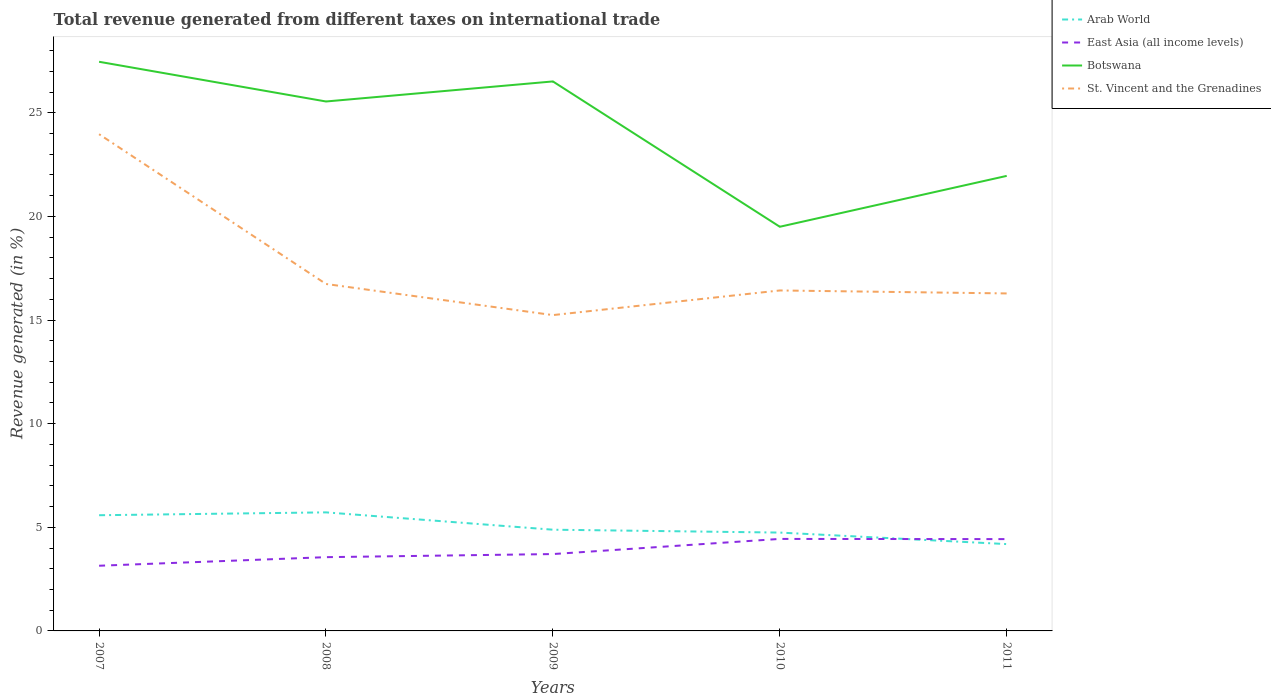How many different coloured lines are there?
Your response must be concise. 4. Across all years, what is the maximum total revenue generated in St. Vincent and the Grenadines?
Keep it short and to the point. 15.24. In which year was the total revenue generated in Arab World maximum?
Provide a succinct answer. 2011. What is the total total revenue generated in St. Vincent and the Grenadines in the graph?
Make the answer very short. 0.14. What is the difference between the highest and the second highest total revenue generated in East Asia (all income levels)?
Your answer should be very brief. 1.29. What is the difference between the highest and the lowest total revenue generated in St. Vincent and the Grenadines?
Provide a succinct answer. 1. How many lines are there?
Offer a terse response. 4. How many years are there in the graph?
Provide a short and direct response. 5. What is the difference between two consecutive major ticks on the Y-axis?
Your answer should be compact. 5. Does the graph contain any zero values?
Keep it short and to the point. No. Does the graph contain grids?
Give a very brief answer. No. What is the title of the graph?
Your response must be concise. Total revenue generated from different taxes on international trade. Does "Costa Rica" appear as one of the legend labels in the graph?
Provide a succinct answer. No. What is the label or title of the Y-axis?
Your answer should be compact. Revenue generated (in %). What is the Revenue generated (in %) in Arab World in 2007?
Make the answer very short. 5.58. What is the Revenue generated (in %) of East Asia (all income levels) in 2007?
Your answer should be very brief. 3.14. What is the Revenue generated (in %) in Botswana in 2007?
Ensure brevity in your answer.  27.46. What is the Revenue generated (in %) in St. Vincent and the Grenadines in 2007?
Your response must be concise. 23.96. What is the Revenue generated (in %) of Arab World in 2008?
Keep it short and to the point. 5.72. What is the Revenue generated (in %) in East Asia (all income levels) in 2008?
Provide a short and direct response. 3.56. What is the Revenue generated (in %) of Botswana in 2008?
Give a very brief answer. 25.54. What is the Revenue generated (in %) of St. Vincent and the Grenadines in 2008?
Your answer should be very brief. 16.74. What is the Revenue generated (in %) in Arab World in 2009?
Your answer should be very brief. 4.88. What is the Revenue generated (in %) of East Asia (all income levels) in 2009?
Your answer should be compact. 3.71. What is the Revenue generated (in %) of Botswana in 2009?
Keep it short and to the point. 26.51. What is the Revenue generated (in %) in St. Vincent and the Grenadines in 2009?
Provide a succinct answer. 15.24. What is the Revenue generated (in %) in Arab World in 2010?
Make the answer very short. 4.74. What is the Revenue generated (in %) in East Asia (all income levels) in 2010?
Give a very brief answer. 4.44. What is the Revenue generated (in %) of Botswana in 2010?
Your response must be concise. 19.5. What is the Revenue generated (in %) in St. Vincent and the Grenadines in 2010?
Offer a very short reply. 16.43. What is the Revenue generated (in %) in Arab World in 2011?
Keep it short and to the point. 4.19. What is the Revenue generated (in %) of East Asia (all income levels) in 2011?
Offer a very short reply. 4.43. What is the Revenue generated (in %) in Botswana in 2011?
Provide a short and direct response. 21.95. What is the Revenue generated (in %) in St. Vincent and the Grenadines in 2011?
Provide a succinct answer. 16.28. Across all years, what is the maximum Revenue generated (in %) of Arab World?
Make the answer very short. 5.72. Across all years, what is the maximum Revenue generated (in %) in East Asia (all income levels)?
Provide a short and direct response. 4.44. Across all years, what is the maximum Revenue generated (in %) of Botswana?
Provide a succinct answer. 27.46. Across all years, what is the maximum Revenue generated (in %) of St. Vincent and the Grenadines?
Make the answer very short. 23.96. Across all years, what is the minimum Revenue generated (in %) in Arab World?
Offer a very short reply. 4.19. Across all years, what is the minimum Revenue generated (in %) in East Asia (all income levels)?
Provide a short and direct response. 3.14. Across all years, what is the minimum Revenue generated (in %) of Botswana?
Your answer should be very brief. 19.5. Across all years, what is the minimum Revenue generated (in %) of St. Vincent and the Grenadines?
Provide a succinct answer. 15.24. What is the total Revenue generated (in %) of Arab World in the graph?
Ensure brevity in your answer.  25.12. What is the total Revenue generated (in %) of East Asia (all income levels) in the graph?
Make the answer very short. 19.28. What is the total Revenue generated (in %) in Botswana in the graph?
Your answer should be compact. 120.96. What is the total Revenue generated (in %) of St. Vincent and the Grenadines in the graph?
Ensure brevity in your answer.  88.65. What is the difference between the Revenue generated (in %) of Arab World in 2007 and that in 2008?
Make the answer very short. -0.14. What is the difference between the Revenue generated (in %) of East Asia (all income levels) in 2007 and that in 2008?
Offer a very short reply. -0.41. What is the difference between the Revenue generated (in %) in Botswana in 2007 and that in 2008?
Your answer should be very brief. 1.92. What is the difference between the Revenue generated (in %) of St. Vincent and the Grenadines in 2007 and that in 2008?
Your answer should be compact. 7.23. What is the difference between the Revenue generated (in %) in Arab World in 2007 and that in 2009?
Your answer should be very brief. 0.7. What is the difference between the Revenue generated (in %) of East Asia (all income levels) in 2007 and that in 2009?
Ensure brevity in your answer.  -0.56. What is the difference between the Revenue generated (in %) of Botswana in 2007 and that in 2009?
Your response must be concise. 0.95. What is the difference between the Revenue generated (in %) of St. Vincent and the Grenadines in 2007 and that in 2009?
Your answer should be very brief. 8.73. What is the difference between the Revenue generated (in %) of Arab World in 2007 and that in 2010?
Ensure brevity in your answer.  0.84. What is the difference between the Revenue generated (in %) in East Asia (all income levels) in 2007 and that in 2010?
Ensure brevity in your answer.  -1.29. What is the difference between the Revenue generated (in %) of Botswana in 2007 and that in 2010?
Offer a terse response. 7.96. What is the difference between the Revenue generated (in %) in St. Vincent and the Grenadines in 2007 and that in 2010?
Provide a short and direct response. 7.54. What is the difference between the Revenue generated (in %) in Arab World in 2007 and that in 2011?
Your answer should be very brief. 1.39. What is the difference between the Revenue generated (in %) in East Asia (all income levels) in 2007 and that in 2011?
Ensure brevity in your answer.  -1.28. What is the difference between the Revenue generated (in %) in Botswana in 2007 and that in 2011?
Give a very brief answer. 5.51. What is the difference between the Revenue generated (in %) in St. Vincent and the Grenadines in 2007 and that in 2011?
Provide a succinct answer. 7.68. What is the difference between the Revenue generated (in %) of Arab World in 2008 and that in 2009?
Your answer should be very brief. 0.84. What is the difference between the Revenue generated (in %) of East Asia (all income levels) in 2008 and that in 2009?
Ensure brevity in your answer.  -0.15. What is the difference between the Revenue generated (in %) of Botswana in 2008 and that in 2009?
Offer a very short reply. -0.97. What is the difference between the Revenue generated (in %) in St. Vincent and the Grenadines in 2008 and that in 2009?
Your answer should be compact. 1.5. What is the difference between the Revenue generated (in %) in Arab World in 2008 and that in 2010?
Keep it short and to the point. 0.97. What is the difference between the Revenue generated (in %) in East Asia (all income levels) in 2008 and that in 2010?
Keep it short and to the point. -0.88. What is the difference between the Revenue generated (in %) of Botswana in 2008 and that in 2010?
Your answer should be compact. 6.04. What is the difference between the Revenue generated (in %) of St. Vincent and the Grenadines in 2008 and that in 2010?
Provide a short and direct response. 0.31. What is the difference between the Revenue generated (in %) of Arab World in 2008 and that in 2011?
Keep it short and to the point. 1.53. What is the difference between the Revenue generated (in %) in East Asia (all income levels) in 2008 and that in 2011?
Offer a very short reply. -0.87. What is the difference between the Revenue generated (in %) of Botswana in 2008 and that in 2011?
Your answer should be very brief. 3.59. What is the difference between the Revenue generated (in %) in St. Vincent and the Grenadines in 2008 and that in 2011?
Offer a terse response. 0.46. What is the difference between the Revenue generated (in %) of Arab World in 2009 and that in 2010?
Give a very brief answer. 0.14. What is the difference between the Revenue generated (in %) of East Asia (all income levels) in 2009 and that in 2010?
Give a very brief answer. -0.73. What is the difference between the Revenue generated (in %) in Botswana in 2009 and that in 2010?
Your answer should be very brief. 7.01. What is the difference between the Revenue generated (in %) in St. Vincent and the Grenadines in 2009 and that in 2010?
Make the answer very short. -1.19. What is the difference between the Revenue generated (in %) in Arab World in 2009 and that in 2011?
Ensure brevity in your answer.  0.69. What is the difference between the Revenue generated (in %) of East Asia (all income levels) in 2009 and that in 2011?
Offer a terse response. -0.72. What is the difference between the Revenue generated (in %) of Botswana in 2009 and that in 2011?
Your answer should be very brief. 4.56. What is the difference between the Revenue generated (in %) in St. Vincent and the Grenadines in 2009 and that in 2011?
Keep it short and to the point. -1.04. What is the difference between the Revenue generated (in %) of Arab World in 2010 and that in 2011?
Your response must be concise. 0.56. What is the difference between the Revenue generated (in %) of East Asia (all income levels) in 2010 and that in 2011?
Give a very brief answer. 0.01. What is the difference between the Revenue generated (in %) in Botswana in 2010 and that in 2011?
Your answer should be very brief. -2.45. What is the difference between the Revenue generated (in %) in St. Vincent and the Grenadines in 2010 and that in 2011?
Make the answer very short. 0.14. What is the difference between the Revenue generated (in %) of Arab World in 2007 and the Revenue generated (in %) of East Asia (all income levels) in 2008?
Make the answer very short. 2.02. What is the difference between the Revenue generated (in %) of Arab World in 2007 and the Revenue generated (in %) of Botswana in 2008?
Ensure brevity in your answer.  -19.96. What is the difference between the Revenue generated (in %) of Arab World in 2007 and the Revenue generated (in %) of St. Vincent and the Grenadines in 2008?
Your answer should be very brief. -11.16. What is the difference between the Revenue generated (in %) in East Asia (all income levels) in 2007 and the Revenue generated (in %) in Botswana in 2008?
Provide a succinct answer. -22.4. What is the difference between the Revenue generated (in %) in East Asia (all income levels) in 2007 and the Revenue generated (in %) in St. Vincent and the Grenadines in 2008?
Offer a very short reply. -13.59. What is the difference between the Revenue generated (in %) of Botswana in 2007 and the Revenue generated (in %) of St. Vincent and the Grenadines in 2008?
Provide a short and direct response. 10.72. What is the difference between the Revenue generated (in %) in Arab World in 2007 and the Revenue generated (in %) in East Asia (all income levels) in 2009?
Ensure brevity in your answer.  1.87. What is the difference between the Revenue generated (in %) of Arab World in 2007 and the Revenue generated (in %) of Botswana in 2009?
Provide a succinct answer. -20.93. What is the difference between the Revenue generated (in %) in Arab World in 2007 and the Revenue generated (in %) in St. Vincent and the Grenadines in 2009?
Keep it short and to the point. -9.66. What is the difference between the Revenue generated (in %) of East Asia (all income levels) in 2007 and the Revenue generated (in %) of Botswana in 2009?
Provide a short and direct response. -23.37. What is the difference between the Revenue generated (in %) of East Asia (all income levels) in 2007 and the Revenue generated (in %) of St. Vincent and the Grenadines in 2009?
Offer a very short reply. -12.09. What is the difference between the Revenue generated (in %) in Botswana in 2007 and the Revenue generated (in %) in St. Vincent and the Grenadines in 2009?
Offer a terse response. 12.22. What is the difference between the Revenue generated (in %) of Arab World in 2007 and the Revenue generated (in %) of East Asia (all income levels) in 2010?
Offer a very short reply. 1.14. What is the difference between the Revenue generated (in %) in Arab World in 2007 and the Revenue generated (in %) in Botswana in 2010?
Keep it short and to the point. -13.92. What is the difference between the Revenue generated (in %) of Arab World in 2007 and the Revenue generated (in %) of St. Vincent and the Grenadines in 2010?
Keep it short and to the point. -10.84. What is the difference between the Revenue generated (in %) in East Asia (all income levels) in 2007 and the Revenue generated (in %) in Botswana in 2010?
Your answer should be compact. -16.35. What is the difference between the Revenue generated (in %) in East Asia (all income levels) in 2007 and the Revenue generated (in %) in St. Vincent and the Grenadines in 2010?
Keep it short and to the point. -13.28. What is the difference between the Revenue generated (in %) of Botswana in 2007 and the Revenue generated (in %) of St. Vincent and the Grenadines in 2010?
Provide a short and direct response. 11.03. What is the difference between the Revenue generated (in %) of Arab World in 2007 and the Revenue generated (in %) of East Asia (all income levels) in 2011?
Your answer should be very brief. 1.15. What is the difference between the Revenue generated (in %) in Arab World in 2007 and the Revenue generated (in %) in Botswana in 2011?
Make the answer very short. -16.37. What is the difference between the Revenue generated (in %) in Arab World in 2007 and the Revenue generated (in %) in St. Vincent and the Grenadines in 2011?
Give a very brief answer. -10.7. What is the difference between the Revenue generated (in %) in East Asia (all income levels) in 2007 and the Revenue generated (in %) in Botswana in 2011?
Make the answer very short. -18.81. What is the difference between the Revenue generated (in %) of East Asia (all income levels) in 2007 and the Revenue generated (in %) of St. Vincent and the Grenadines in 2011?
Make the answer very short. -13.14. What is the difference between the Revenue generated (in %) of Botswana in 2007 and the Revenue generated (in %) of St. Vincent and the Grenadines in 2011?
Give a very brief answer. 11.18. What is the difference between the Revenue generated (in %) of Arab World in 2008 and the Revenue generated (in %) of East Asia (all income levels) in 2009?
Give a very brief answer. 2.01. What is the difference between the Revenue generated (in %) in Arab World in 2008 and the Revenue generated (in %) in Botswana in 2009?
Your response must be concise. -20.79. What is the difference between the Revenue generated (in %) in Arab World in 2008 and the Revenue generated (in %) in St. Vincent and the Grenadines in 2009?
Ensure brevity in your answer.  -9.52. What is the difference between the Revenue generated (in %) in East Asia (all income levels) in 2008 and the Revenue generated (in %) in Botswana in 2009?
Keep it short and to the point. -22.95. What is the difference between the Revenue generated (in %) of East Asia (all income levels) in 2008 and the Revenue generated (in %) of St. Vincent and the Grenadines in 2009?
Provide a short and direct response. -11.68. What is the difference between the Revenue generated (in %) of Botswana in 2008 and the Revenue generated (in %) of St. Vincent and the Grenadines in 2009?
Make the answer very short. 10.31. What is the difference between the Revenue generated (in %) in Arab World in 2008 and the Revenue generated (in %) in East Asia (all income levels) in 2010?
Provide a succinct answer. 1.28. What is the difference between the Revenue generated (in %) in Arab World in 2008 and the Revenue generated (in %) in Botswana in 2010?
Offer a terse response. -13.78. What is the difference between the Revenue generated (in %) in Arab World in 2008 and the Revenue generated (in %) in St. Vincent and the Grenadines in 2010?
Ensure brevity in your answer.  -10.71. What is the difference between the Revenue generated (in %) of East Asia (all income levels) in 2008 and the Revenue generated (in %) of Botswana in 2010?
Your answer should be compact. -15.94. What is the difference between the Revenue generated (in %) of East Asia (all income levels) in 2008 and the Revenue generated (in %) of St. Vincent and the Grenadines in 2010?
Offer a very short reply. -12.87. What is the difference between the Revenue generated (in %) of Botswana in 2008 and the Revenue generated (in %) of St. Vincent and the Grenadines in 2010?
Keep it short and to the point. 9.12. What is the difference between the Revenue generated (in %) of Arab World in 2008 and the Revenue generated (in %) of East Asia (all income levels) in 2011?
Offer a very short reply. 1.29. What is the difference between the Revenue generated (in %) in Arab World in 2008 and the Revenue generated (in %) in Botswana in 2011?
Offer a very short reply. -16.23. What is the difference between the Revenue generated (in %) of Arab World in 2008 and the Revenue generated (in %) of St. Vincent and the Grenadines in 2011?
Ensure brevity in your answer.  -10.56. What is the difference between the Revenue generated (in %) in East Asia (all income levels) in 2008 and the Revenue generated (in %) in Botswana in 2011?
Your answer should be very brief. -18.39. What is the difference between the Revenue generated (in %) of East Asia (all income levels) in 2008 and the Revenue generated (in %) of St. Vincent and the Grenadines in 2011?
Give a very brief answer. -12.72. What is the difference between the Revenue generated (in %) of Botswana in 2008 and the Revenue generated (in %) of St. Vincent and the Grenadines in 2011?
Your answer should be very brief. 9.26. What is the difference between the Revenue generated (in %) of Arab World in 2009 and the Revenue generated (in %) of East Asia (all income levels) in 2010?
Your answer should be compact. 0.44. What is the difference between the Revenue generated (in %) in Arab World in 2009 and the Revenue generated (in %) in Botswana in 2010?
Make the answer very short. -14.62. What is the difference between the Revenue generated (in %) in Arab World in 2009 and the Revenue generated (in %) in St. Vincent and the Grenadines in 2010?
Your response must be concise. -11.54. What is the difference between the Revenue generated (in %) of East Asia (all income levels) in 2009 and the Revenue generated (in %) of Botswana in 2010?
Give a very brief answer. -15.79. What is the difference between the Revenue generated (in %) in East Asia (all income levels) in 2009 and the Revenue generated (in %) in St. Vincent and the Grenadines in 2010?
Offer a terse response. -12.72. What is the difference between the Revenue generated (in %) of Botswana in 2009 and the Revenue generated (in %) of St. Vincent and the Grenadines in 2010?
Your answer should be compact. 10.08. What is the difference between the Revenue generated (in %) in Arab World in 2009 and the Revenue generated (in %) in East Asia (all income levels) in 2011?
Provide a succinct answer. 0.45. What is the difference between the Revenue generated (in %) of Arab World in 2009 and the Revenue generated (in %) of Botswana in 2011?
Offer a very short reply. -17.07. What is the difference between the Revenue generated (in %) of Arab World in 2009 and the Revenue generated (in %) of St. Vincent and the Grenadines in 2011?
Ensure brevity in your answer.  -11.4. What is the difference between the Revenue generated (in %) of East Asia (all income levels) in 2009 and the Revenue generated (in %) of Botswana in 2011?
Offer a terse response. -18.25. What is the difference between the Revenue generated (in %) of East Asia (all income levels) in 2009 and the Revenue generated (in %) of St. Vincent and the Grenadines in 2011?
Provide a succinct answer. -12.57. What is the difference between the Revenue generated (in %) of Botswana in 2009 and the Revenue generated (in %) of St. Vincent and the Grenadines in 2011?
Make the answer very short. 10.23. What is the difference between the Revenue generated (in %) in Arab World in 2010 and the Revenue generated (in %) in East Asia (all income levels) in 2011?
Make the answer very short. 0.32. What is the difference between the Revenue generated (in %) in Arab World in 2010 and the Revenue generated (in %) in Botswana in 2011?
Keep it short and to the point. -17.21. What is the difference between the Revenue generated (in %) in Arab World in 2010 and the Revenue generated (in %) in St. Vincent and the Grenadines in 2011?
Offer a terse response. -11.54. What is the difference between the Revenue generated (in %) of East Asia (all income levels) in 2010 and the Revenue generated (in %) of Botswana in 2011?
Provide a short and direct response. -17.51. What is the difference between the Revenue generated (in %) of East Asia (all income levels) in 2010 and the Revenue generated (in %) of St. Vincent and the Grenadines in 2011?
Give a very brief answer. -11.84. What is the difference between the Revenue generated (in %) of Botswana in 2010 and the Revenue generated (in %) of St. Vincent and the Grenadines in 2011?
Your answer should be very brief. 3.22. What is the average Revenue generated (in %) in Arab World per year?
Your answer should be very brief. 5.02. What is the average Revenue generated (in %) in East Asia (all income levels) per year?
Keep it short and to the point. 3.86. What is the average Revenue generated (in %) of Botswana per year?
Your answer should be compact. 24.19. What is the average Revenue generated (in %) in St. Vincent and the Grenadines per year?
Keep it short and to the point. 17.73. In the year 2007, what is the difference between the Revenue generated (in %) of Arab World and Revenue generated (in %) of East Asia (all income levels)?
Your response must be concise. 2.44. In the year 2007, what is the difference between the Revenue generated (in %) of Arab World and Revenue generated (in %) of Botswana?
Your response must be concise. -21.88. In the year 2007, what is the difference between the Revenue generated (in %) in Arab World and Revenue generated (in %) in St. Vincent and the Grenadines?
Provide a short and direct response. -18.38. In the year 2007, what is the difference between the Revenue generated (in %) of East Asia (all income levels) and Revenue generated (in %) of Botswana?
Your answer should be very brief. -24.31. In the year 2007, what is the difference between the Revenue generated (in %) of East Asia (all income levels) and Revenue generated (in %) of St. Vincent and the Grenadines?
Offer a very short reply. -20.82. In the year 2007, what is the difference between the Revenue generated (in %) of Botswana and Revenue generated (in %) of St. Vincent and the Grenadines?
Keep it short and to the point. 3.49. In the year 2008, what is the difference between the Revenue generated (in %) in Arab World and Revenue generated (in %) in East Asia (all income levels)?
Keep it short and to the point. 2.16. In the year 2008, what is the difference between the Revenue generated (in %) in Arab World and Revenue generated (in %) in Botswana?
Your answer should be compact. -19.82. In the year 2008, what is the difference between the Revenue generated (in %) of Arab World and Revenue generated (in %) of St. Vincent and the Grenadines?
Your answer should be very brief. -11.02. In the year 2008, what is the difference between the Revenue generated (in %) in East Asia (all income levels) and Revenue generated (in %) in Botswana?
Provide a succinct answer. -21.98. In the year 2008, what is the difference between the Revenue generated (in %) in East Asia (all income levels) and Revenue generated (in %) in St. Vincent and the Grenadines?
Offer a very short reply. -13.18. In the year 2008, what is the difference between the Revenue generated (in %) in Botswana and Revenue generated (in %) in St. Vincent and the Grenadines?
Provide a succinct answer. 8.8. In the year 2009, what is the difference between the Revenue generated (in %) in Arab World and Revenue generated (in %) in East Asia (all income levels)?
Ensure brevity in your answer.  1.18. In the year 2009, what is the difference between the Revenue generated (in %) of Arab World and Revenue generated (in %) of Botswana?
Give a very brief answer. -21.63. In the year 2009, what is the difference between the Revenue generated (in %) in Arab World and Revenue generated (in %) in St. Vincent and the Grenadines?
Your response must be concise. -10.35. In the year 2009, what is the difference between the Revenue generated (in %) in East Asia (all income levels) and Revenue generated (in %) in Botswana?
Provide a short and direct response. -22.8. In the year 2009, what is the difference between the Revenue generated (in %) of East Asia (all income levels) and Revenue generated (in %) of St. Vincent and the Grenadines?
Ensure brevity in your answer.  -11.53. In the year 2009, what is the difference between the Revenue generated (in %) of Botswana and Revenue generated (in %) of St. Vincent and the Grenadines?
Offer a very short reply. 11.27. In the year 2010, what is the difference between the Revenue generated (in %) in Arab World and Revenue generated (in %) in East Asia (all income levels)?
Provide a succinct answer. 0.31. In the year 2010, what is the difference between the Revenue generated (in %) of Arab World and Revenue generated (in %) of Botswana?
Your answer should be compact. -14.75. In the year 2010, what is the difference between the Revenue generated (in %) of Arab World and Revenue generated (in %) of St. Vincent and the Grenadines?
Your response must be concise. -11.68. In the year 2010, what is the difference between the Revenue generated (in %) of East Asia (all income levels) and Revenue generated (in %) of Botswana?
Make the answer very short. -15.06. In the year 2010, what is the difference between the Revenue generated (in %) of East Asia (all income levels) and Revenue generated (in %) of St. Vincent and the Grenadines?
Your answer should be very brief. -11.99. In the year 2010, what is the difference between the Revenue generated (in %) in Botswana and Revenue generated (in %) in St. Vincent and the Grenadines?
Your answer should be very brief. 3.07. In the year 2011, what is the difference between the Revenue generated (in %) of Arab World and Revenue generated (in %) of East Asia (all income levels)?
Offer a very short reply. -0.24. In the year 2011, what is the difference between the Revenue generated (in %) of Arab World and Revenue generated (in %) of Botswana?
Give a very brief answer. -17.76. In the year 2011, what is the difference between the Revenue generated (in %) in Arab World and Revenue generated (in %) in St. Vincent and the Grenadines?
Keep it short and to the point. -12.09. In the year 2011, what is the difference between the Revenue generated (in %) in East Asia (all income levels) and Revenue generated (in %) in Botswana?
Keep it short and to the point. -17.52. In the year 2011, what is the difference between the Revenue generated (in %) of East Asia (all income levels) and Revenue generated (in %) of St. Vincent and the Grenadines?
Provide a short and direct response. -11.85. In the year 2011, what is the difference between the Revenue generated (in %) in Botswana and Revenue generated (in %) in St. Vincent and the Grenadines?
Ensure brevity in your answer.  5.67. What is the ratio of the Revenue generated (in %) of Arab World in 2007 to that in 2008?
Your answer should be compact. 0.98. What is the ratio of the Revenue generated (in %) of East Asia (all income levels) in 2007 to that in 2008?
Give a very brief answer. 0.88. What is the ratio of the Revenue generated (in %) in Botswana in 2007 to that in 2008?
Your answer should be compact. 1.07. What is the ratio of the Revenue generated (in %) of St. Vincent and the Grenadines in 2007 to that in 2008?
Make the answer very short. 1.43. What is the ratio of the Revenue generated (in %) of Arab World in 2007 to that in 2009?
Your answer should be compact. 1.14. What is the ratio of the Revenue generated (in %) of East Asia (all income levels) in 2007 to that in 2009?
Keep it short and to the point. 0.85. What is the ratio of the Revenue generated (in %) in Botswana in 2007 to that in 2009?
Ensure brevity in your answer.  1.04. What is the ratio of the Revenue generated (in %) in St. Vincent and the Grenadines in 2007 to that in 2009?
Offer a terse response. 1.57. What is the ratio of the Revenue generated (in %) of Arab World in 2007 to that in 2010?
Make the answer very short. 1.18. What is the ratio of the Revenue generated (in %) in East Asia (all income levels) in 2007 to that in 2010?
Make the answer very short. 0.71. What is the ratio of the Revenue generated (in %) of Botswana in 2007 to that in 2010?
Keep it short and to the point. 1.41. What is the ratio of the Revenue generated (in %) of St. Vincent and the Grenadines in 2007 to that in 2010?
Offer a terse response. 1.46. What is the ratio of the Revenue generated (in %) of Arab World in 2007 to that in 2011?
Your response must be concise. 1.33. What is the ratio of the Revenue generated (in %) of East Asia (all income levels) in 2007 to that in 2011?
Your response must be concise. 0.71. What is the ratio of the Revenue generated (in %) of Botswana in 2007 to that in 2011?
Provide a short and direct response. 1.25. What is the ratio of the Revenue generated (in %) in St. Vincent and the Grenadines in 2007 to that in 2011?
Keep it short and to the point. 1.47. What is the ratio of the Revenue generated (in %) of Arab World in 2008 to that in 2009?
Your response must be concise. 1.17. What is the ratio of the Revenue generated (in %) in East Asia (all income levels) in 2008 to that in 2009?
Make the answer very short. 0.96. What is the ratio of the Revenue generated (in %) in Botswana in 2008 to that in 2009?
Offer a terse response. 0.96. What is the ratio of the Revenue generated (in %) of St. Vincent and the Grenadines in 2008 to that in 2009?
Your answer should be very brief. 1.1. What is the ratio of the Revenue generated (in %) of Arab World in 2008 to that in 2010?
Ensure brevity in your answer.  1.21. What is the ratio of the Revenue generated (in %) in East Asia (all income levels) in 2008 to that in 2010?
Your answer should be compact. 0.8. What is the ratio of the Revenue generated (in %) in Botswana in 2008 to that in 2010?
Make the answer very short. 1.31. What is the ratio of the Revenue generated (in %) in St. Vincent and the Grenadines in 2008 to that in 2010?
Offer a terse response. 1.02. What is the ratio of the Revenue generated (in %) in Arab World in 2008 to that in 2011?
Your answer should be very brief. 1.37. What is the ratio of the Revenue generated (in %) of East Asia (all income levels) in 2008 to that in 2011?
Give a very brief answer. 0.8. What is the ratio of the Revenue generated (in %) in Botswana in 2008 to that in 2011?
Provide a succinct answer. 1.16. What is the ratio of the Revenue generated (in %) of St. Vincent and the Grenadines in 2008 to that in 2011?
Give a very brief answer. 1.03. What is the ratio of the Revenue generated (in %) of Arab World in 2009 to that in 2010?
Ensure brevity in your answer.  1.03. What is the ratio of the Revenue generated (in %) of East Asia (all income levels) in 2009 to that in 2010?
Ensure brevity in your answer.  0.84. What is the ratio of the Revenue generated (in %) in Botswana in 2009 to that in 2010?
Offer a very short reply. 1.36. What is the ratio of the Revenue generated (in %) in St. Vincent and the Grenadines in 2009 to that in 2010?
Make the answer very short. 0.93. What is the ratio of the Revenue generated (in %) of Arab World in 2009 to that in 2011?
Your answer should be compact. 1.17. What is the ratio of the Revenue generated (in %) of East Asia (all income levels) in 2009 to that in 2011?
Provide a short and direct response. 0.84. What is the ratio of the Revenue generated (in %) of Botswana in 2009 to that in 2011?
Ensure brevity in your answer.  1.21. What is the ratio of the Revenue generated (in %) in St. Vincent and the Grenadines in 2009 to that in 2011?
Your answer should be compact. 0.94. What is the ratio of the Revenue generated (in %) of Arab World in 2010 to that in 2011?
Offer a terse response. 1.13. What is the ratio of the Revenue generated (in %) in East Asia (all income levels) in 2010 to that in 2011?
Offer a terse response. 1. What is the ratio of the Revenue generated (in %) in Botswana in 2010 to that in 2011?
Your answer should be compact. 0.89. What is the ratio of the Revenue generated (in %) of St. Vincent and the Grenadines in 2010 to that in 2011?
Provide a short and direct response. 1.01. What is the difference between the highest and the second highest Revenue generated (in %) in Arab World?
Provide a succinct answer. 0.14. What is the difference between the highest and the second highest Revenue generated (in %) in East Asia (all income levels)?
Provide a short and direct response. 0.01. What is the difference between the highest and the second highest Revenue generated (in %) in Botswana?
Offer a very short reply. 0.95. What is the difference between the highest and the second highest Revenue generated (in %) in St. Vincent and the Grenadines?
Offer a very short reply. 7.23. What is the difference between the highest and the lowest Revenue generated (in %) in Arab World?
Offer a terse response. 1.53. What is the difference between the highest and the lowest Revenue generated (in %) in East Asia (all income levels)?
Provide a succinct answer. 1.29. What is the difference between the highest and the lowest Revenue generated (in %) in Botswana?
Provide a short and direct response. 7.96. What is the difference between the highest and the lowest Revenue generated (in %) in St. Vincent and the Grenadines?
Offer a terse response. 8.73. 